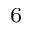<formula> <loc_0><loc_0><loc_500><loc_500>^ { 6 }</formula> 